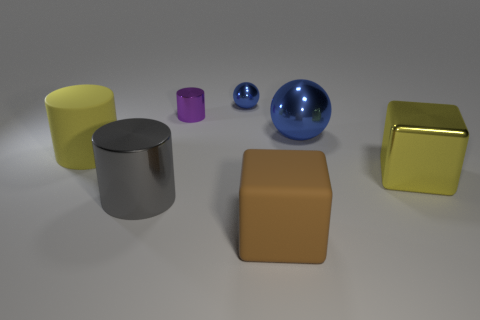Add 3 tiny purple blocks. How many objects exist? 10 Subtract all balls. How many objects are left? 5 Subtract 0 red cylinders. How many objects are left? 7 Subtract all gray things. Subtract all small cylinders. How many objects are left? 5 Add 3 yellow matte cylinders. How many yellow matte cylinders are left? 4 Add 6 large brown matte blocks. How many large brown matte blocks exist? 7 